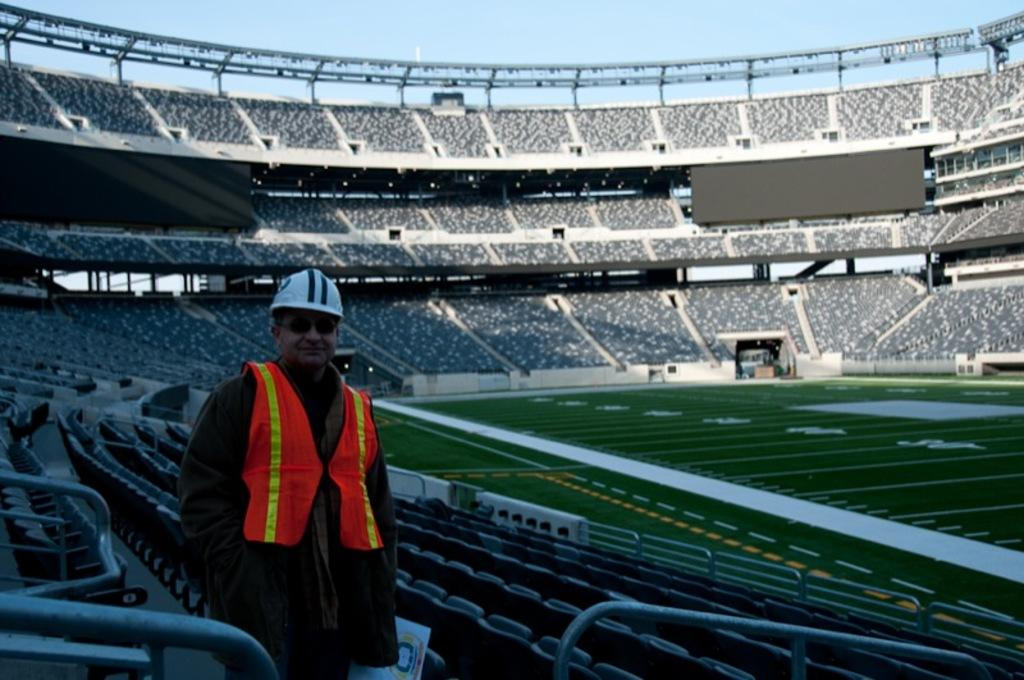Where was the image taken? The image was taken inside a stadium. What type of seating is available in the stadium? There are chairs in the image. Can you describe the person in the image? There is a person standing in the image. What can be seen towards the right side of the image? The ground is visible towards the right side of the image. What is visible at the top of the image? The sky is visible at the top of the image. What type of popcorn is being sold at the competition in the image? There is no competition or popcorn present in the image. 